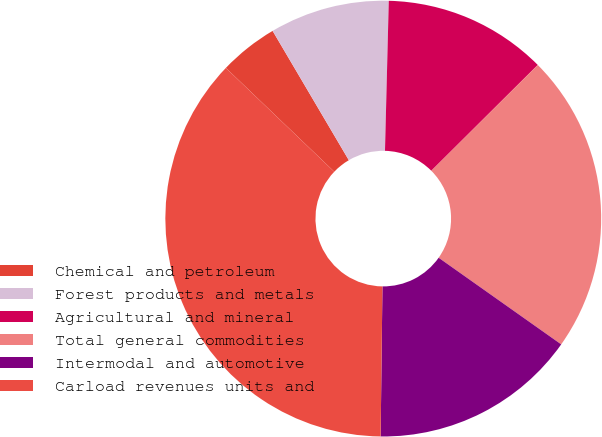<chart> <loc_0><loc_0><loc_500><loc_500><pie_chart><fcel>Chemical and petroleum<fcel>Forest products and metals<fcel>Agricultural and mineral<fcel>Total general commodities<fcel>Intermodal and automotive<fcel>Carload revenues units and<nl><fcel>4.37%<fcel>8.88%<fcel>12.14%<fcel>22.25%<fcel>15.4%<fcel>36.96%<nl></chart> 